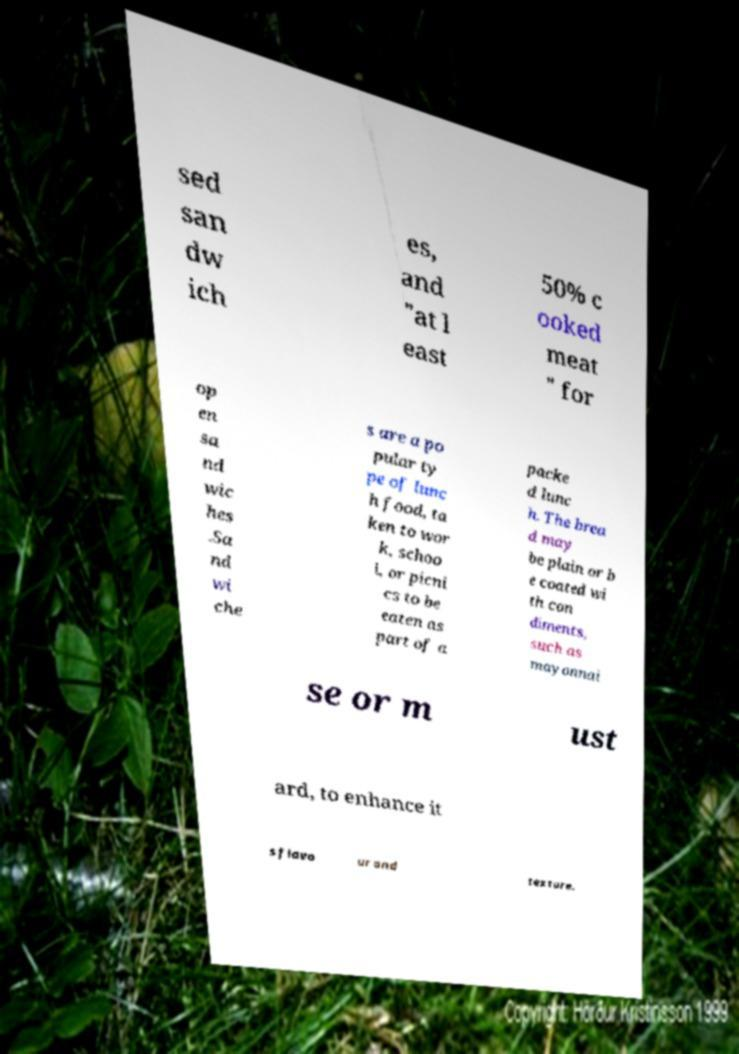Can you accurately transcribe the text from the provided image for me? sed san dw ich es, and "at l east 50% c ooked meat " for op en sa nd wic hes .Sa nd wi che s are a po pular ty pe of lunc h food, ta ken to wor k, schoo l, or picni cs to be eaten as part of a packe d lunc h. The brea d may be plain or b e coated wi th con diments, such as mayonnai se or m ust ard, to enhance it s flavo ur and texture. 